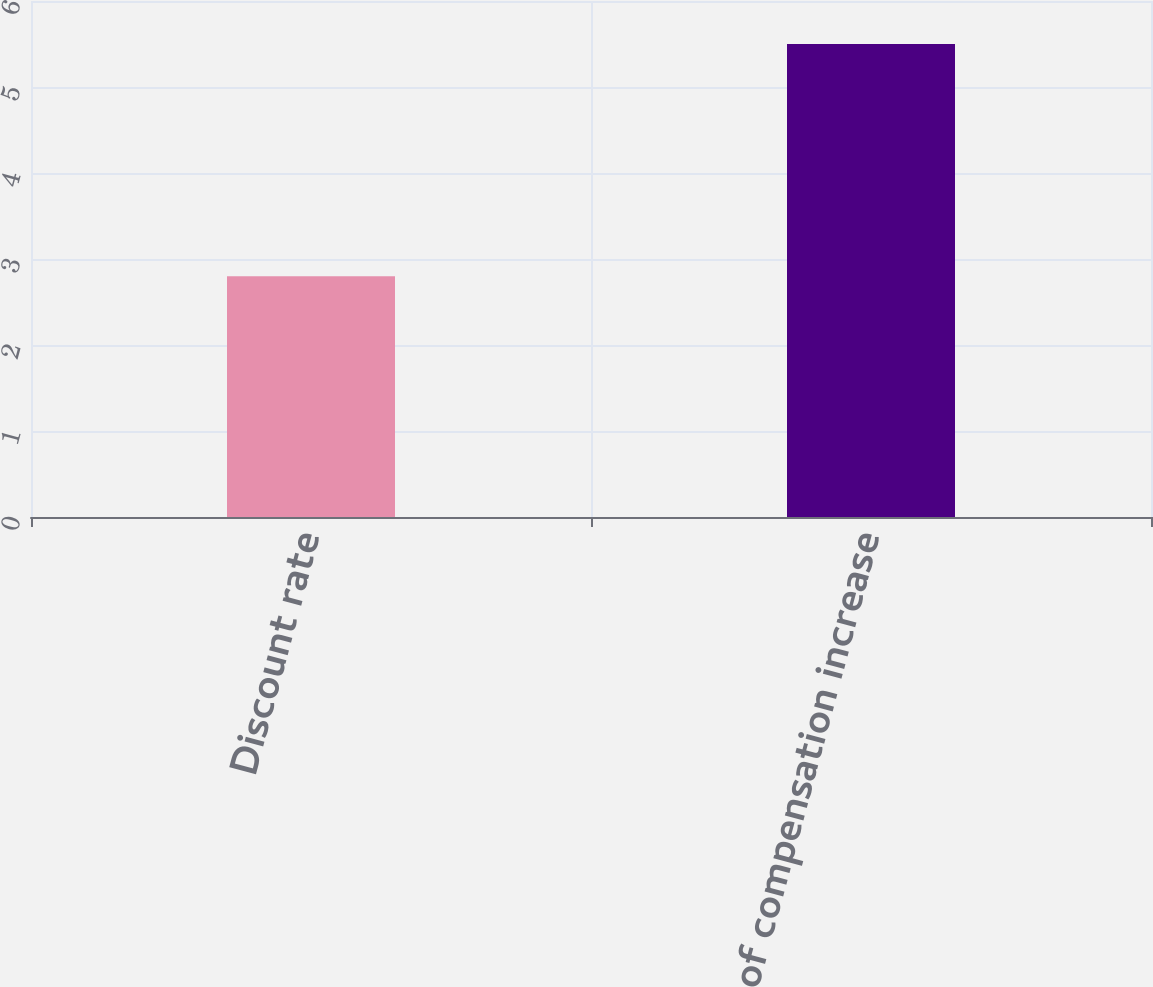<chart> <loc_0><loc_0><loc_500><loc_500><bar_chart><fcel>Discount rate<fcel>Rate of compensation increase<nl><fcel>2.8<fcel>5.5<nl></chart> 